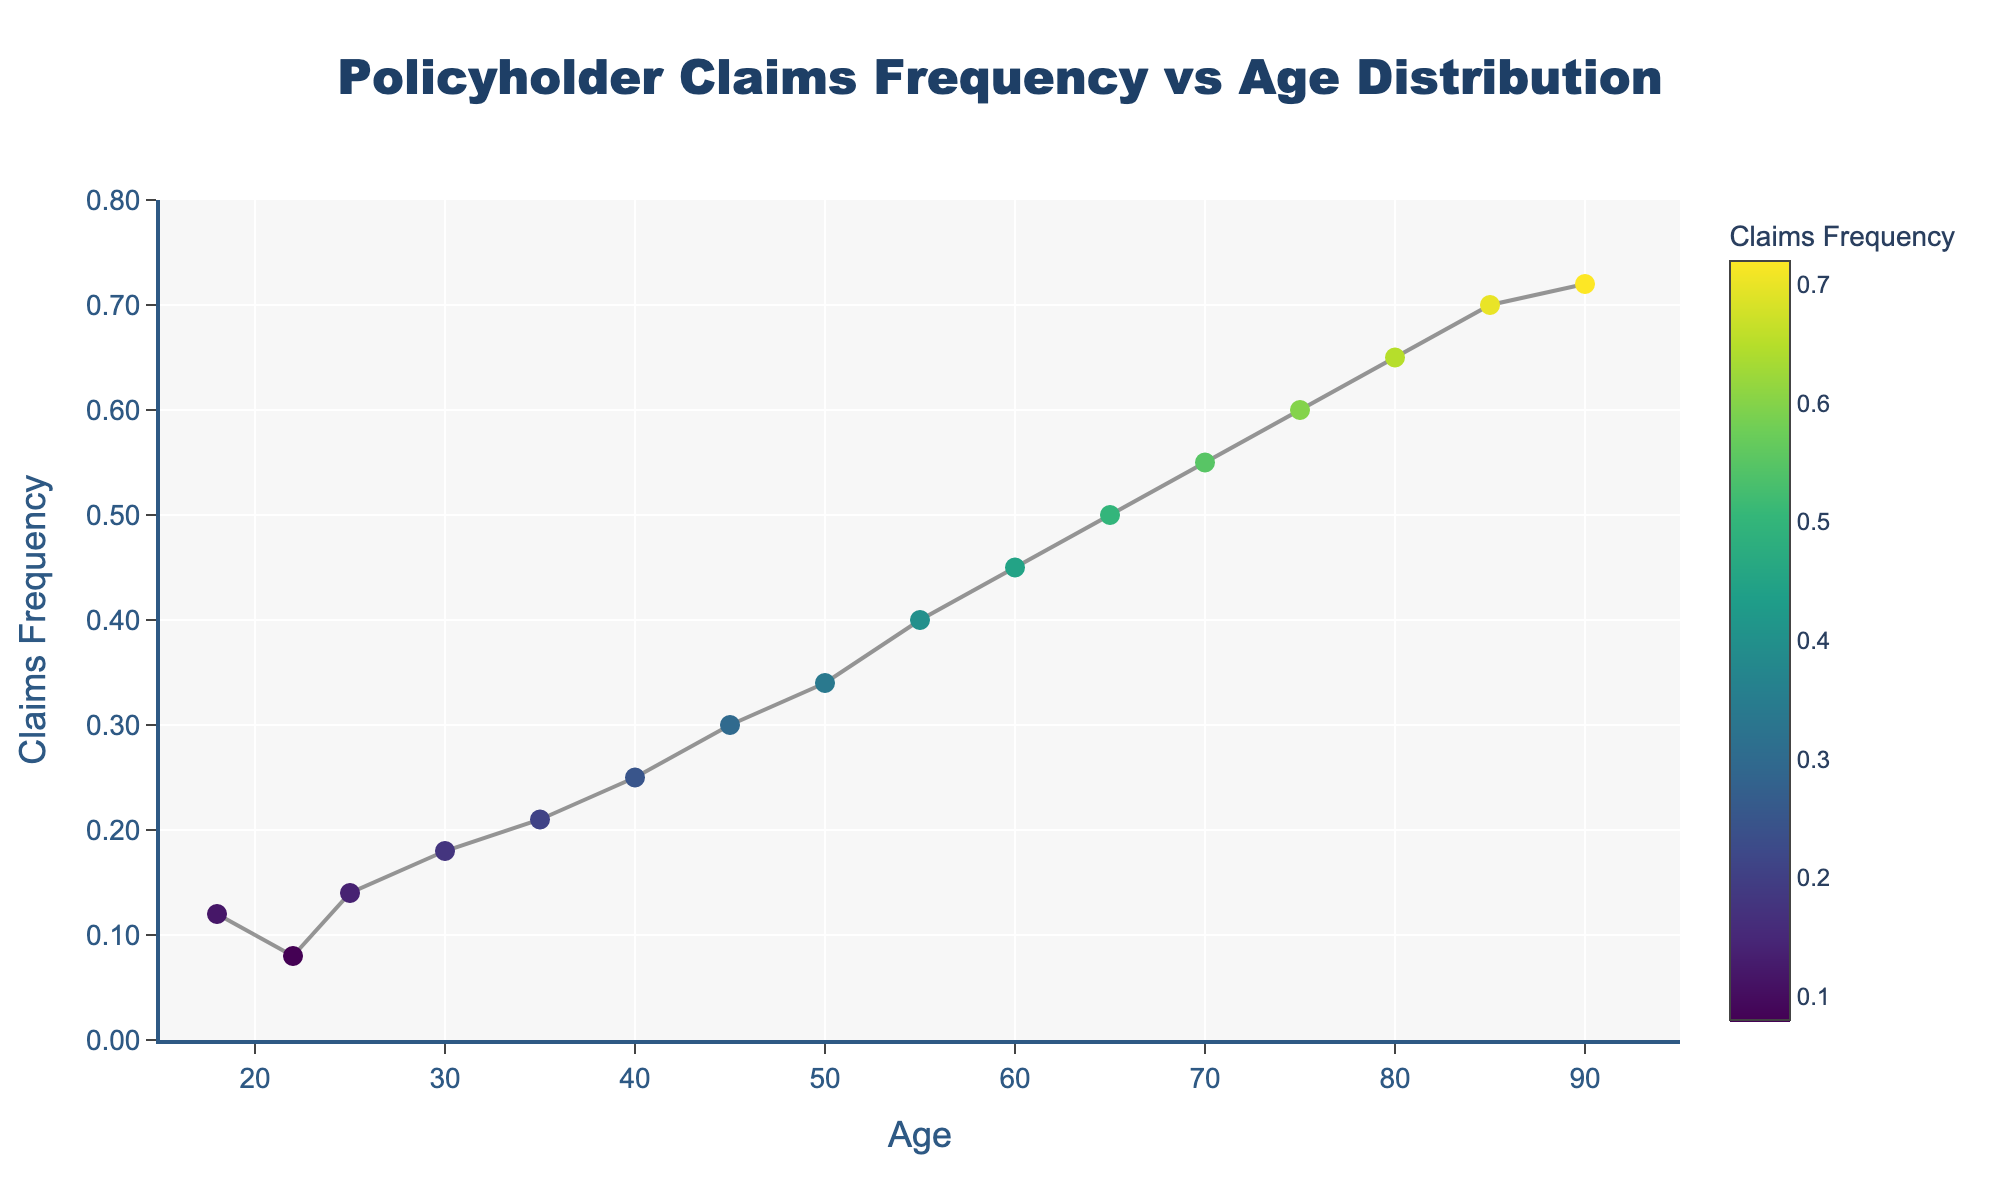What is the title of the scatter plot? Look at the top of the figure where the main heading is placed. The title summarizes the content of the plot.
Answer: Policyholder Claims Frequency vs Age Distribution What is the range of the x-axis? The x-axis represents Age. Check the axis labels to find the starting and ending values. The x-axis ranges from 15 to 95.
Answer: 15 to 95 How many data points are plotted? Each point on the scatter plot represents a data point. Count the number of points shown in the plot. There are 16 data points.
Answer: 16 At what age is the Claims Frequency 0.34? Trace the y-axis up to the value 0.34 and check the corresponding value on the x-axis. This corresponds to Age 50.
Answer: 50 What is the trend of Claims Frequency as Age increases? Observe the general direction in which the data points are plotted. Claims Frequency increases as Age increases.
Answer: Increases Which age group has the highest Claims Frequency? Locate the highest point on the y-axis and find the corresponding age on the x-axis. The highest Claims Frequency (0.72) is at Age 90.
Answer: Age 90 Compare the Claims Frequency of policyholders aged 40 and 60. Check the y-values for the specific ages and compare the two. The Claims Frequency at Age 40 is 0.25, while at Age 60 it is 0.45.
Answer: 0.25 vs. 0.45 Calculate the increase in Claims Frequency from age 30 to age 70. Subtract the Claims Frequency at age 30 from that at age 70. 0.55 - 0.18 = 0.37.
Answer: 0.37 Which age group has a Claims Frequency closest to 0.50? Identify the data point closest to the y-value of 0.50 and check its x-value. This corresponds to Age 65.
Answer: Age 65 What color represents the highest Claims Frequency on the plot? The color scale on the plot indicates Claims Frequency. The highest values are shown in a color towards the end of the scale, which is a shade of yellow.
Answer: Yellow 